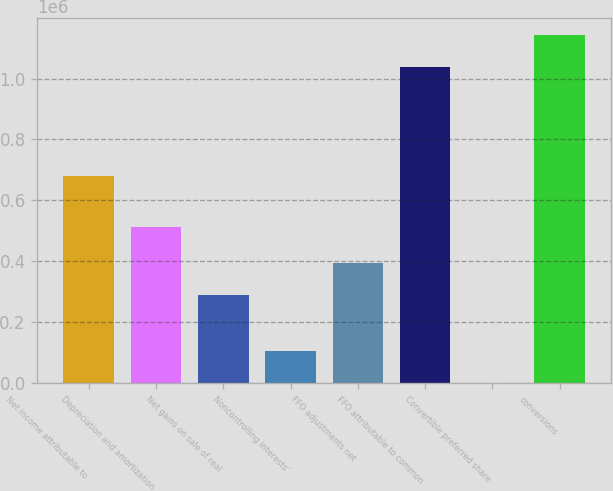Convert chart to OTSL. <chart><loc_0><loc_0><loc_500><loc_500><bar_chart><fcel>Net income attributable to<fcel>Depreciation and amortization<fcel>Net gains on sale of real<fcel>Noncontrolling interests'<fcel>FFO adjustments net<fcel>FFO attributable to common<fcel>Convertible preferred share<fcel>conversions<nl><fcel>679856<fcel>514085<fcel>289117<fcel>103986<fcel>393011<fcel>1.03894e+06<fcel>92<fcel>1.14284e+06<nl></chart> 